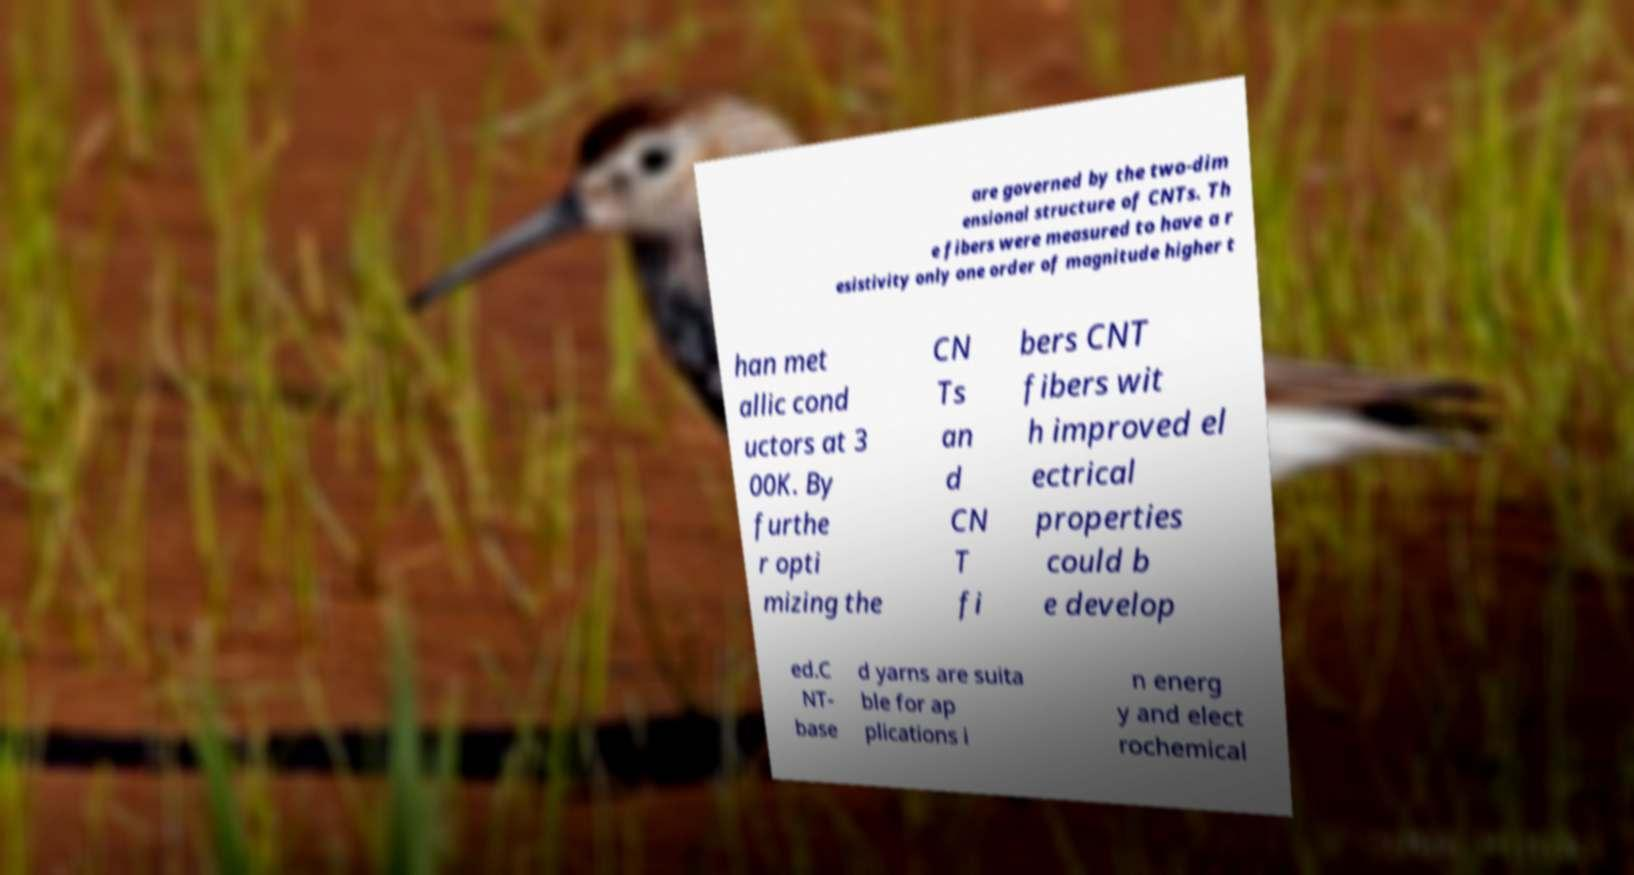Can you accurately transcribe the text from the provided image for me? are governed by the two-dim ensional structure of CNTs. Th e fibers were measured to have a r esistivity only one order of magnitude higher t han met allic cond uctors at 3 00K. By furthe r opti mizing the CN Ts an d CN T fi bers CNT fibers wit h improved el ectrical properties could b e develop ed.C NT- base d yarns are suita ble for ap plications i n energ y and elect rochemical 